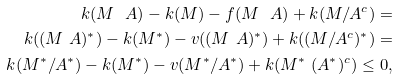Convert formula to latex. <formula><loc_0><loc_0><loc_500><loc_500>k ( M \ A ) - k ( M ) - f ( M \ A ) + k ( M / A ^ { c } ) = \\ k ( ( M \ A ) ^ { * } ) - k ( M ^ { * } ) - v ( ( M \ A ) ^ { * } ) + k ( ( M / A ^ { c } ) ^ { * } ) = \\ k ( M ^ { * } / A ^ { * } ) - k ( M ^ { * } ) - v ( M ^ { * } / A ^ { * } ) + k ( M ^ { * } \ ( A ^ { * } ) ^ { c } ) \leq 0 ,</formula> 